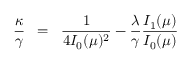Convert formula to latex. <formula><loc_0><loc_0><loc_500><loc_500>\frac { \kappa } { \gamma } \, = \, \frac { 1 } { 4 I _ { 0 } ( \mu ) ^ { 2 } } - \frac { \lambda } { \gamma } \frac { I _ { 1 } ( \mu ) } { I _ { 0 } ( \mu ) }</formula> 